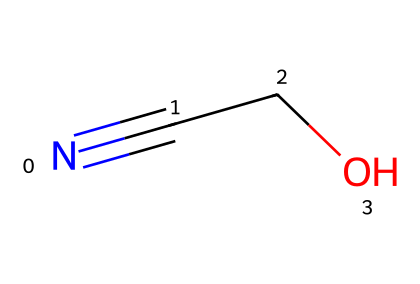What is the molecular formula of azidoethanol? To find the molecular formula, we count the atoms present in the structure. The structure provides a nitrogen atom (N), two carbon atoms (C), and an oxygen atom (O), giving us C2H4N2O. However, azidoethanol specifically focuses on the azide and alcohol functionality, leading to NH2C2H5O. The correct formula is C2H6N2O.
Answer: C2H6N2O How many carbon atoms are present in azidoethanol? By analyzing the structure, there are two carbon atoms (C) connected in the molecule.
Answer: 2 What type of functional group does azidoethanol contain? In the structure, we can identify two functional groups: the azide (-N3) group, which is characteristic of azides, and the hydroxyl (-OH) group, which indicates the presence of an alcohol. Thus, the major functional group is the azide.
Answer: azide What is the total number of atoms in azidoethanol? By counting all the different atoms present: there are 2 carbon atoms (C), 6 hydrogen atoms (H), 2 nitrogen atoms (N), and 1 oxygen atom (O). Adding these gives a total of 11 atoms.
Answer: 11 Which bond type is prominent in the azido group of azidoethanol? The azido group (-N3) consists of a nitrogen triple bond to another nitrogen atom, which is a defining feature. Therefore, the prominent bond type here is a triple bond.
Answer: triple bond 